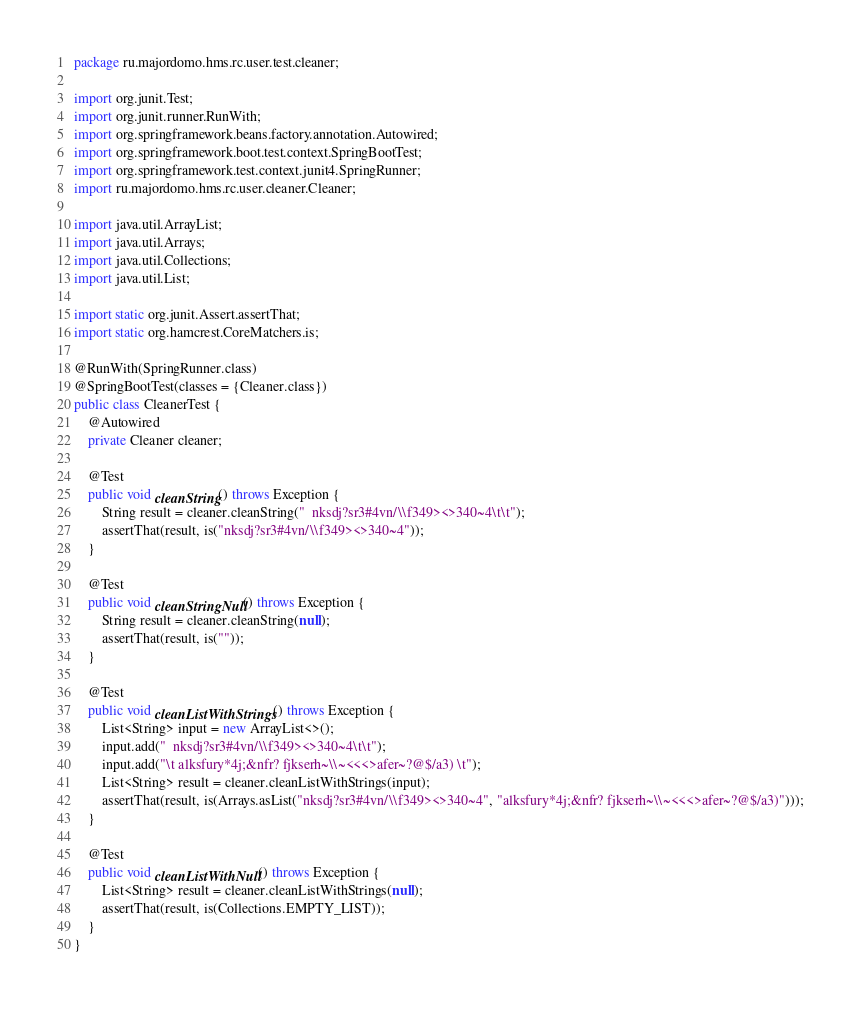<code> <loc_0><loc_0><loc_500><loc_500><_Java_>package ru.majordomo.hms.rc.user.test.cleaner;

import org.junit.Test;
import org.junit.runner.RunWith;
import org.springframework.beans.factory.annotation.Autowired;
import org.springframework.boot.test.context.SpringBootTest;
import org.springframework.test.context.junit4.SpringRunner;
import ru.majordomo.hms.rc.user.cleaner.Cleaner;

import java.util.ArrayList;
import java.util.Arrays;
import java.util.Collections;
import java.util.List;

import static org.junit.Assert.assertThat;
import static org.hamcrest.CoreMatchers.is;

@RunWith(SpringRunner.class)
@SpringBootTest(classes = {Cleaner.class})
public class CleanerTest {
    @Autowired
    private Cleaner cleaner;

    @Test
    public void cleanString() throws Exception {
        String result = cleaner.cleanString("  nksdj?sr3#4vn/\\f349><>340~4\t\t");
        assertThat(result, is("nksdj?sr3#4vn/\\f349><>340~4"));
    }

    @Test
    public void cleanStringNull() throws Exception {
        String result = cleaner.cleanString(null);
        assertThat(result, is(""));
    }

    @Test
    public void cleanListWithStrings() throws Exception {
        List<String> input = new ArrayList<>();
        input.add("  nksdj?sr3#4vn/\\f349><>340~4\t\t");
        input.add("\t alksfury*4j;&nfr? fjkserh~\\~<<<>afer~?@$/a3) \t");
        List<String> result = cleaner.cleanListWithStrings(input);
        assertThat(result, is(Arrays.asList("nksdj?sr3#4vn/\\f349><>340~4", "alksfury*4j;&nfr? fjkserh~\\~<<<>afer~?@$/a3)")));
    }

    @Test
    public void cleanListWithNull() throws Exception {
        List<String> result = cleaner.cleanListWithStrings(null);
        assertThat(result, is(Collections.EMPTY_LIST));
    }
}</code> 